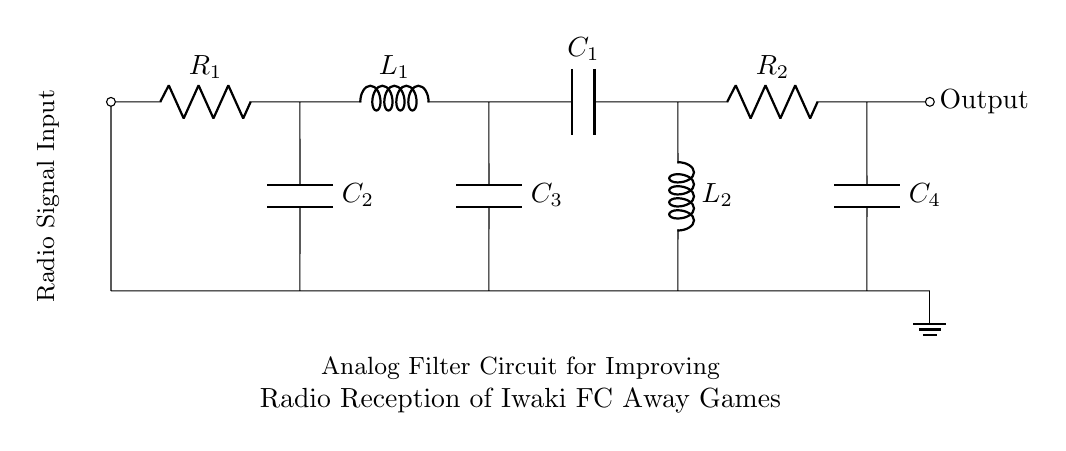What is the first component in the circuit? The first component listed in the circuit is the antenna, which is positioned at the top left of the diagram.
Answer: antenna How many resistors are in the circuit? There are two resistors in the circuit, labeled R1 and R2, located on the upper side of the diagram.
Answer: 2 What is the purpose of the capacitors in this filter circuit? The capacitors (C1, C2, C3, C4) serve to block DC while allowing AC signals to pass, which helps improve radio reception by filtering out unwanted frequencies.
Answer: filter signals Which components are connected in parallel? The capacitors C2, C3, and C4 are connected in parallel with their respective resistors and inductors, providing multiple paths for signal flow.
Answer: C2, C3, C4 What does the output node in the circuit indicate? The output node indicates where the filtered radio signal is taken from, allowing the user to connect it to a radio receiver.
Answer: Output What is the total number of inductors in this circuit? There are two inductors in the circuit, labeled L1 and L2, which are essential for creating frequency-dependent behavior in the filter.
Answer: 2 What is the main function of this analog filter circuit? The main function of the analog filter circuit is to improve the quality of radio signal reception by attenuating unwanted signals during the reception of away games.
Answer: improve reception 